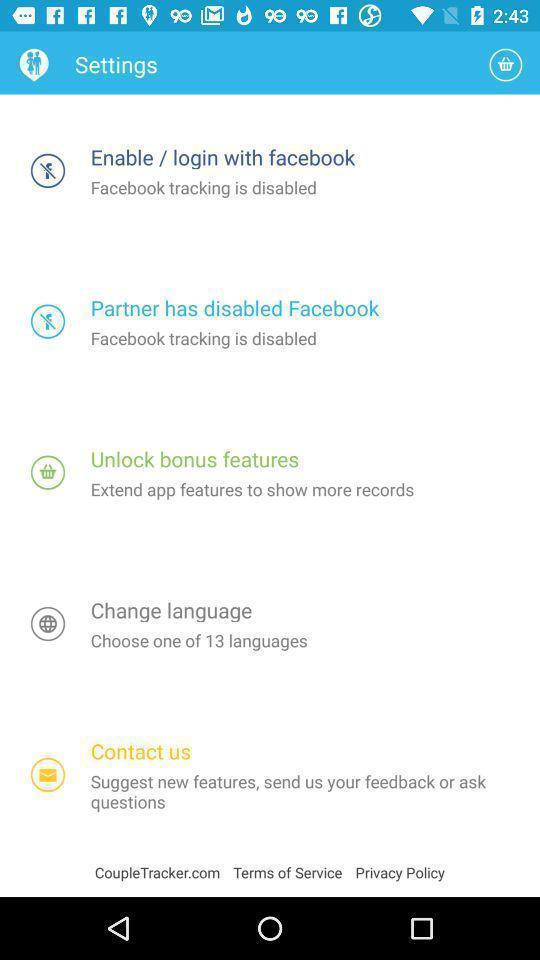Summarize the main components in this picture. Settings tab with different tabs in application. 